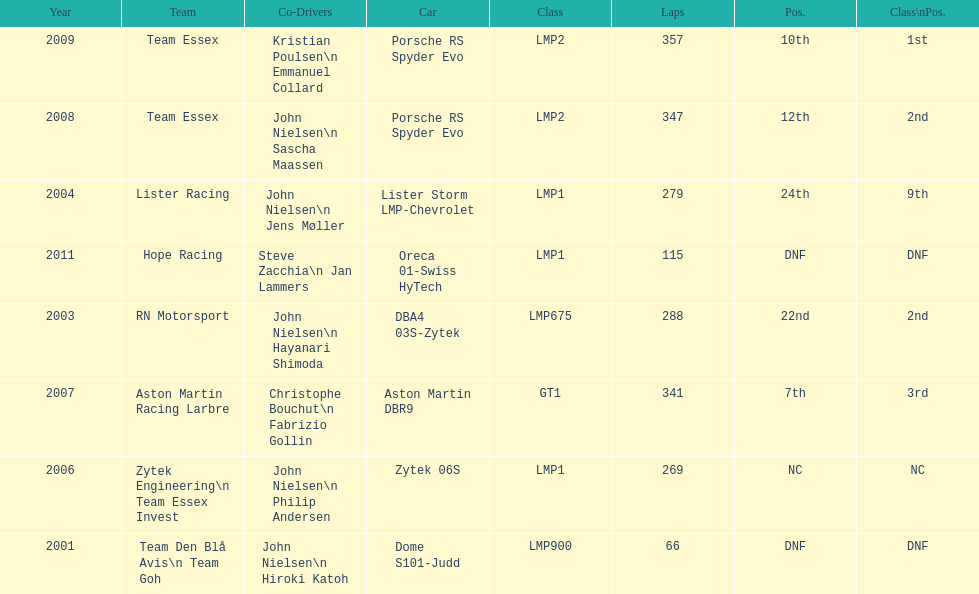Who were the partner drivers for the aston martin dbr9 in 2007? Christophe Bouchut, Fabrizio Gollin. 